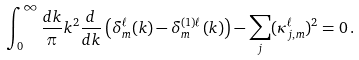Convert formula to latex. <formula><loc_0><loc_0><loc_500><loc_500>\int _ { 0 } ^ { \infty } \frac { d k } { \pi } k ^ { 2 } \frac { d } { d k } \left ( \delta _ { m } ^ { \ell } ( k ) - \delta _ { m } ^ { ( 1 ) \ell } ( k ) \right ) - \sum _ { j } ( \kappa ^ { \ell } _ { j , m } ) ^ { 2 } = 0 \, .</formula> 